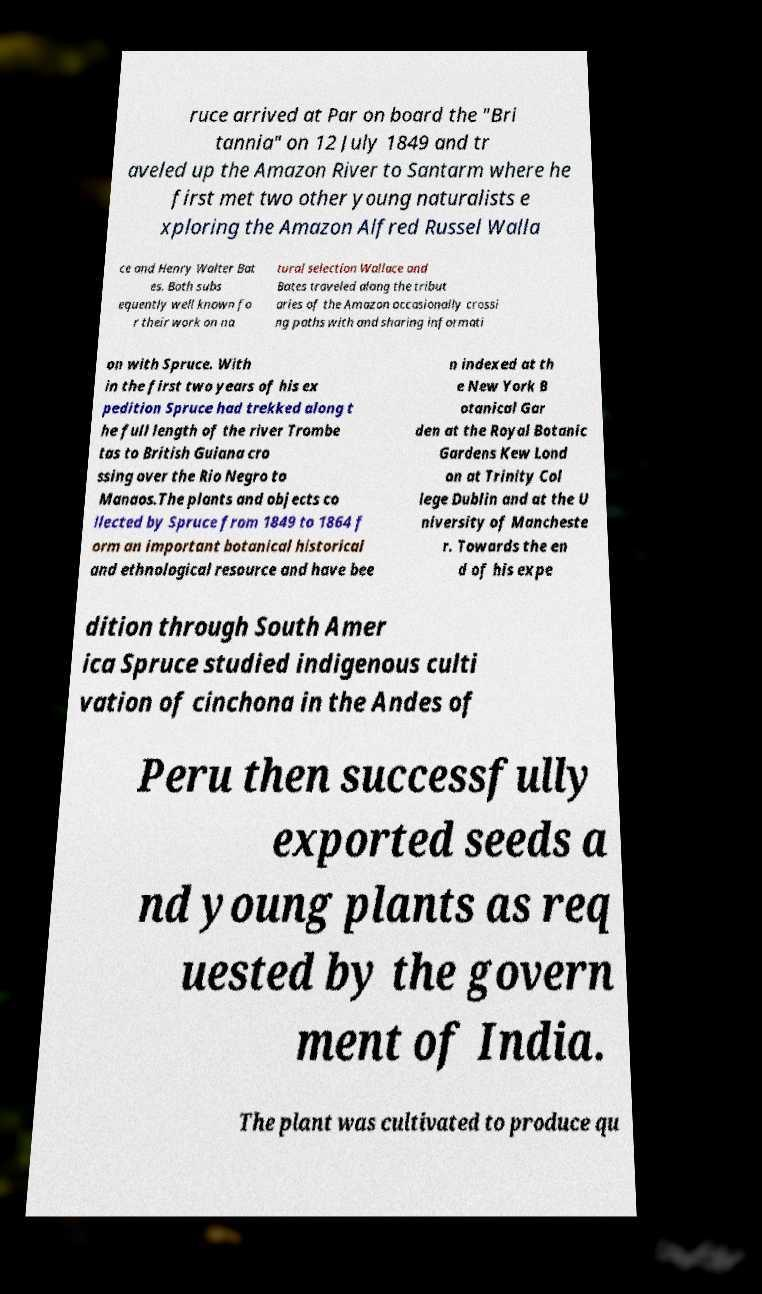What messages or text are displayed in this image? I need them in a readable, typed format. ruce arrived at Par on board the "Bri tannia" on 12 July 1849 and tr aveled up the Amazon River to Santarm where he first met two other young naturalists e xploring the Amazon Alfred Russel Walla ce and Henry Walter Bat es. Both subs equently well known fo r their work on na tural selection Wallace and Bates traveled along the tribut aries of the Amazon occasionally crossi ng paths with and sharing informati on with Spruce. With in the first two years of his ex pedition Spruce had trekked along t he full length of the river Trombe tas to British Guiana cro ssing over the Rio Negro to Manaos.The plants and objects co llected by Spruce from 1849 to 1864 f orm an important botanical historical and ethnological resource and have bee n indexed at th e New York B otanical Gar den at the Royal Botanic Gardens Kew Lond on at Trinity Col lege Dublin and at the U niversity of Mancheste r. Towards the en d of his expe dition through South Amer ica Spruce studied indigenous culti vation of cinchona in the Andes of Peru then successfully exported seeds a nd young plants as req uested by the govern ment of India. The plant was cultivated to produce qu 